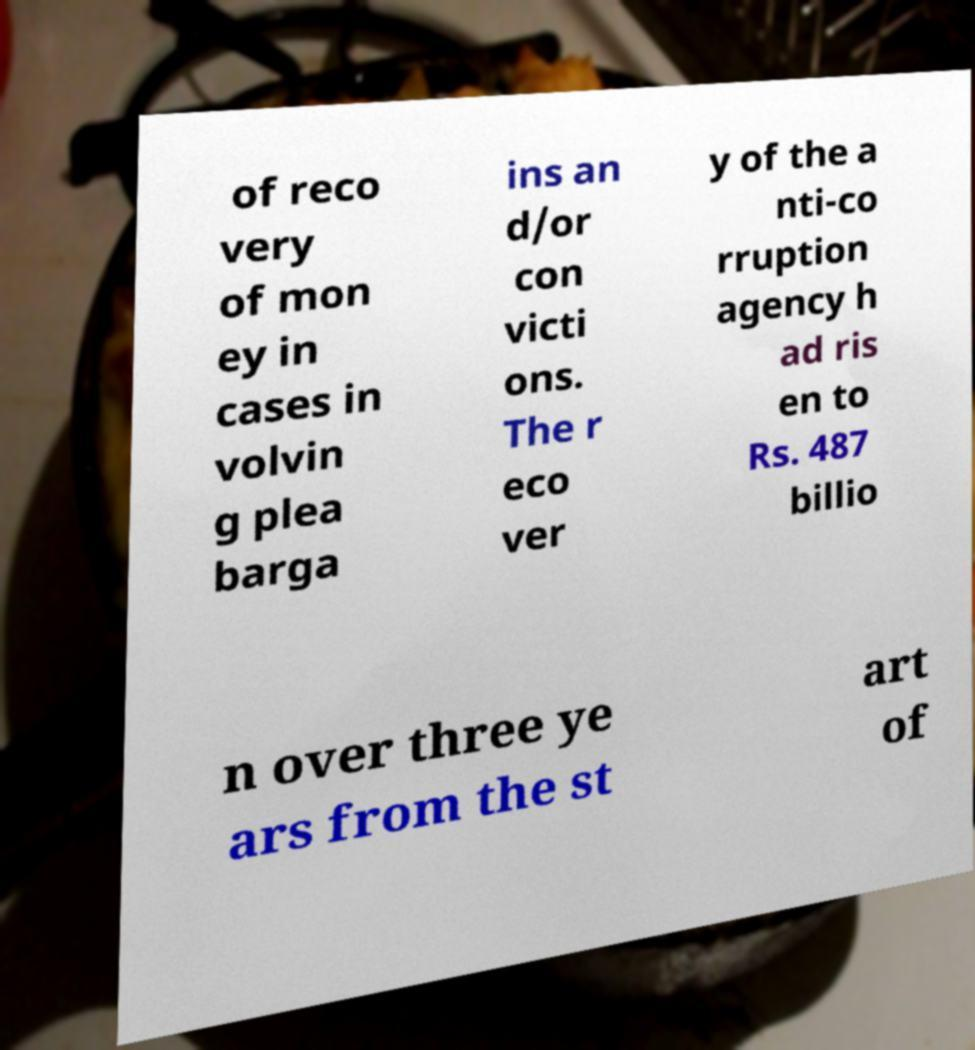I need the written content from this picture converted into text. Can you do that? of reco very of mon ey in cases in volvin g plea barga ins an d/or con victi ons. The r eco ver y of the a nti-co rruption agency h ad ris en to Rs. 487 billio n over three ye ars from the st art of 